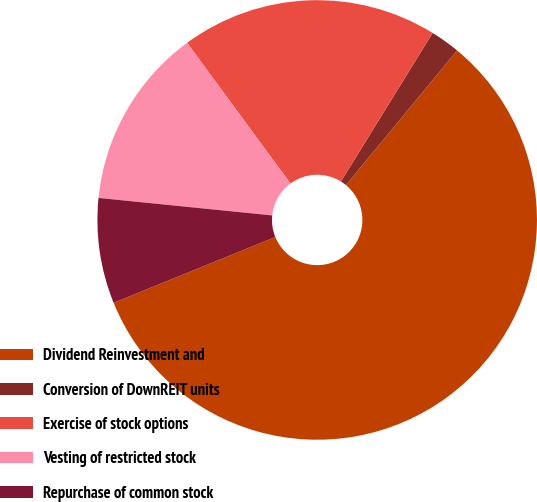<chart> <loc_0><loc_0><loc_500><loc_500><pie_chart><fcel>Dividend Reinvestment and<fcel>Conversion of DownREIT units<fcel>Exercise of stock options<fcel>Vesting of restricted stock<fcel>Repurchase of common stock<nl><fcel>57.87%<fcel>2.18%<fcel>18.89%<fcel>13.32%<fcel>7.75%<nl></chart> 